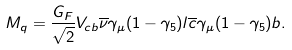<formula> <loc_0><loc_0><loc_500><loc_500>M _ { q } = \frac { G _ { F } } { \sqrt { 2 } } V _ { c b } \overline { \nu } \gamma _ { \mu } ( 1 - \gamma _ { 5 } ) l \overline { c } \gamma _ { \mu } ( 1 - \gamma _ { 5 } ) b .</formula> 